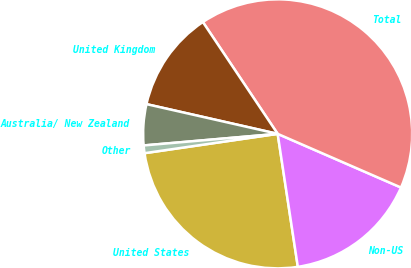<chart> <loc_0><loc_0><loc_500><loc_500><pie_chart><fcel>United States<fcel>Non-US<fcel>Total<fcel>United Kingdom<fcel>Australia/ New Zealand<fcel>Other<nl><fcel>25.1%<fcel>16.07%<fcel>40.92%<fcel>12.07%<fcel>4.92%<fcel>0.92%<nl></chart> 